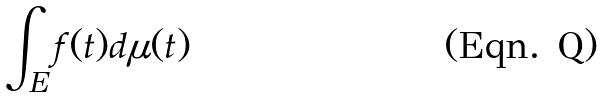<formula> <loc_0><loc_0><loc_500><loc_500>\int _ { E } f ( t ) d \mu ( t )</formula> 